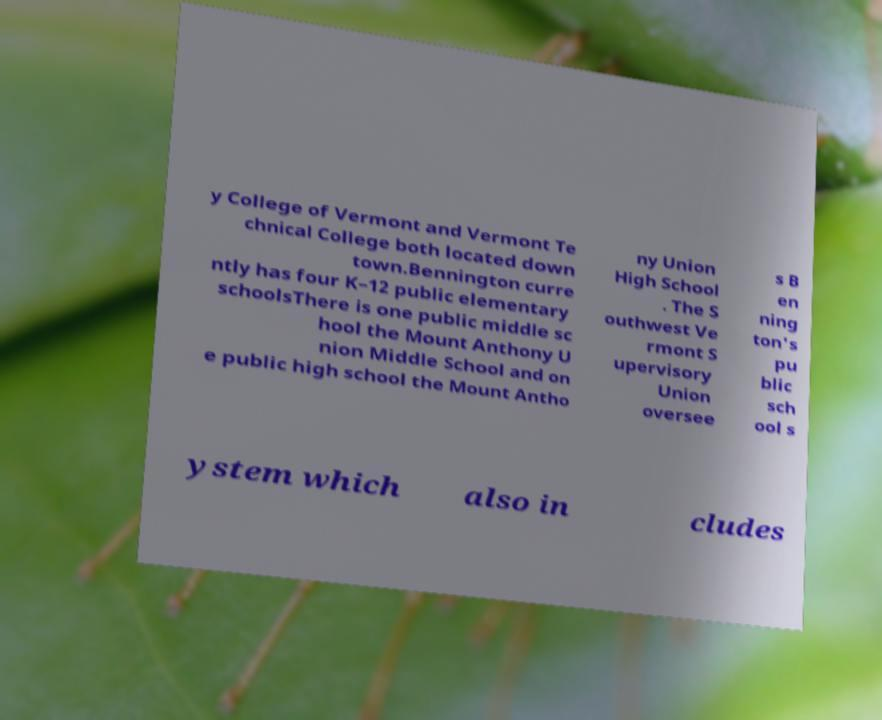Please identify and transcribe the text found in this image. y College of Vermont and Vermont Te chnical College both located down town.Bennington curre ntly has four K–12 public elementary schoolsThere is one public middle sc hool the Mount Anthony U nion Middle School and on e public high school the Mount Antho ny Union High School . The S outhwest Ve rmont S upervisory Union oversee s B en ning ton's pu blic sch ool s ystem which also in cludes 